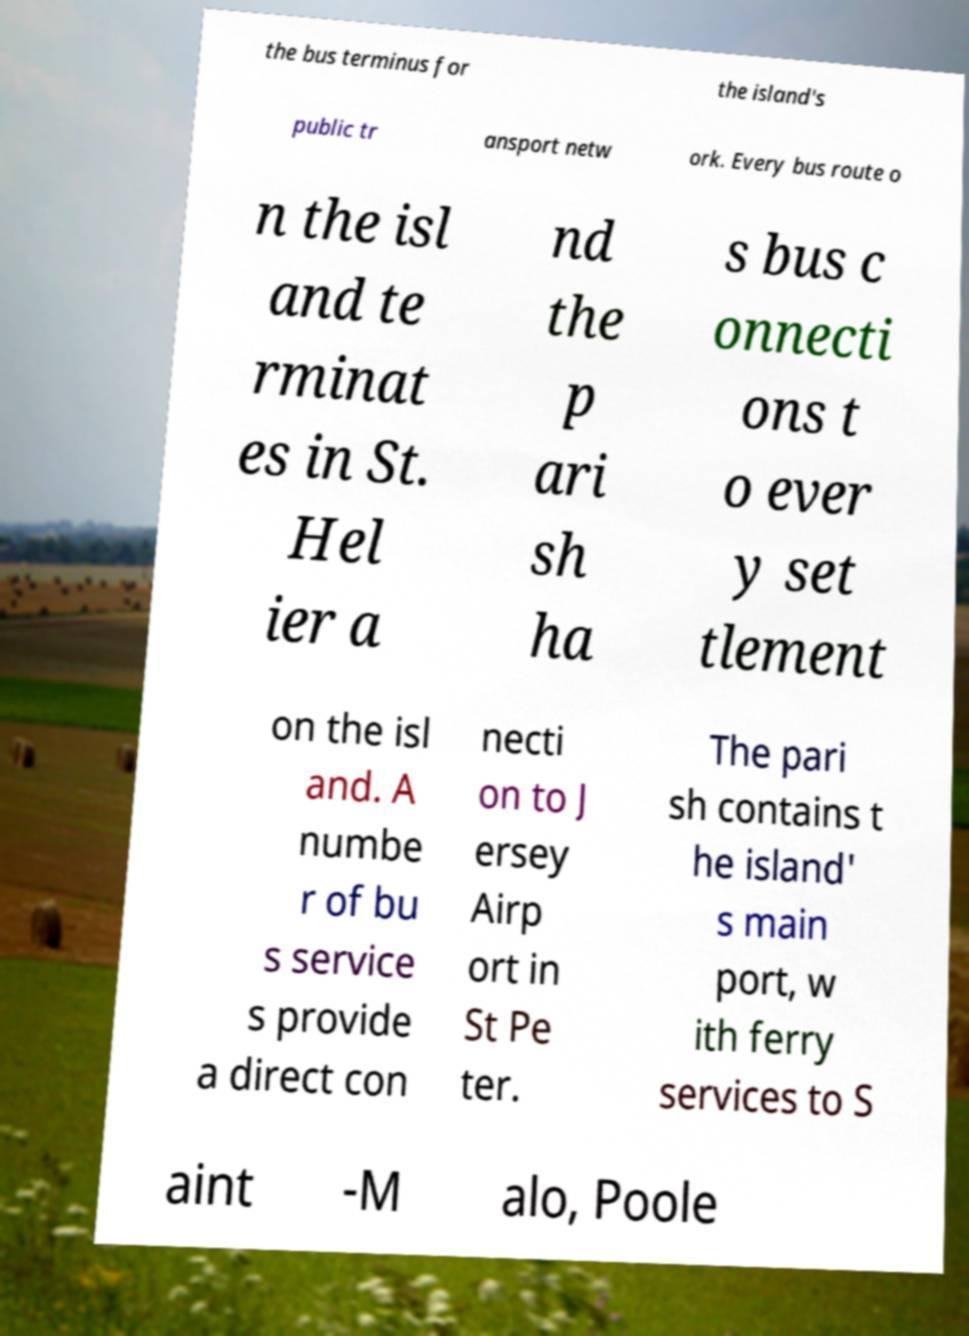What messages or text are displayed in this image? I need them in a readable, typed format. the bus terminus for the island's public tr ansport netw ork. Every bus route o n the isl and te rminat es in St. Hel ier a nd the p ari sh ha s bus c onnecti ons t o ever y set tlement on the isl and. A numbe r of bu s service s provide a direct con necti on to J ersey Airp ort in St Pe ter. The pari sh contains t he island' s main port, w ith ferry services to S aint -M alo, Poole 